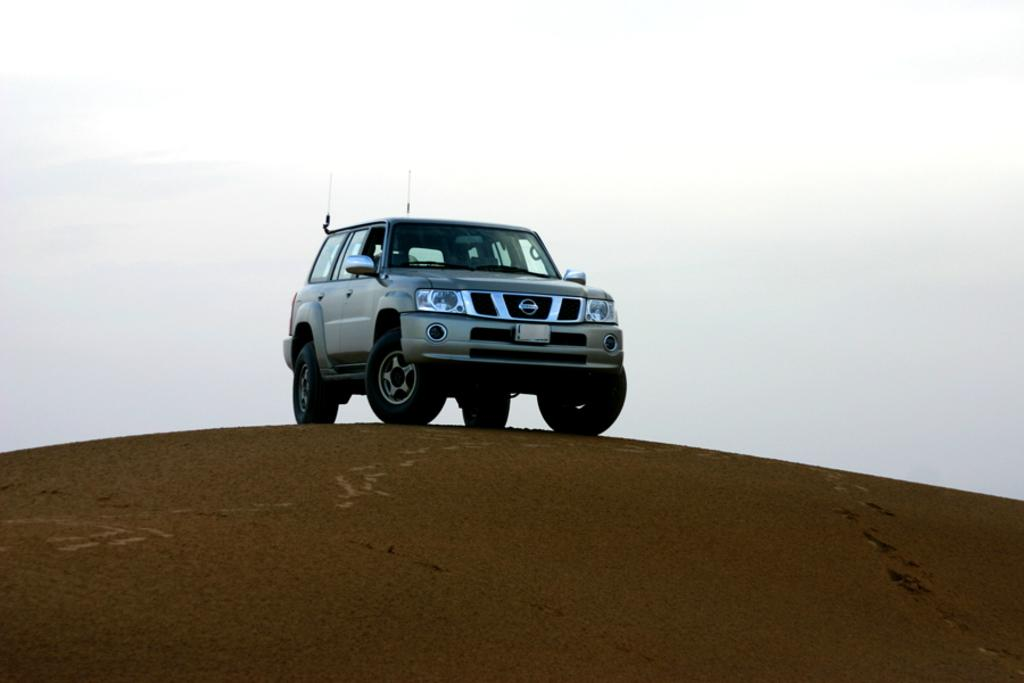What is the main subject of the image? There is a vehicle in the image. Can you describe the position of the vehicle? The vehicle is on the ground. What can be seen in the background of the image? The sky is visible in the background of the image. What type of lipstick is the vehicle wearing in the image? There is no lipstick or any indication of cosmetics in the image; it features a vehicle on the ground with the sky visible in the background. 